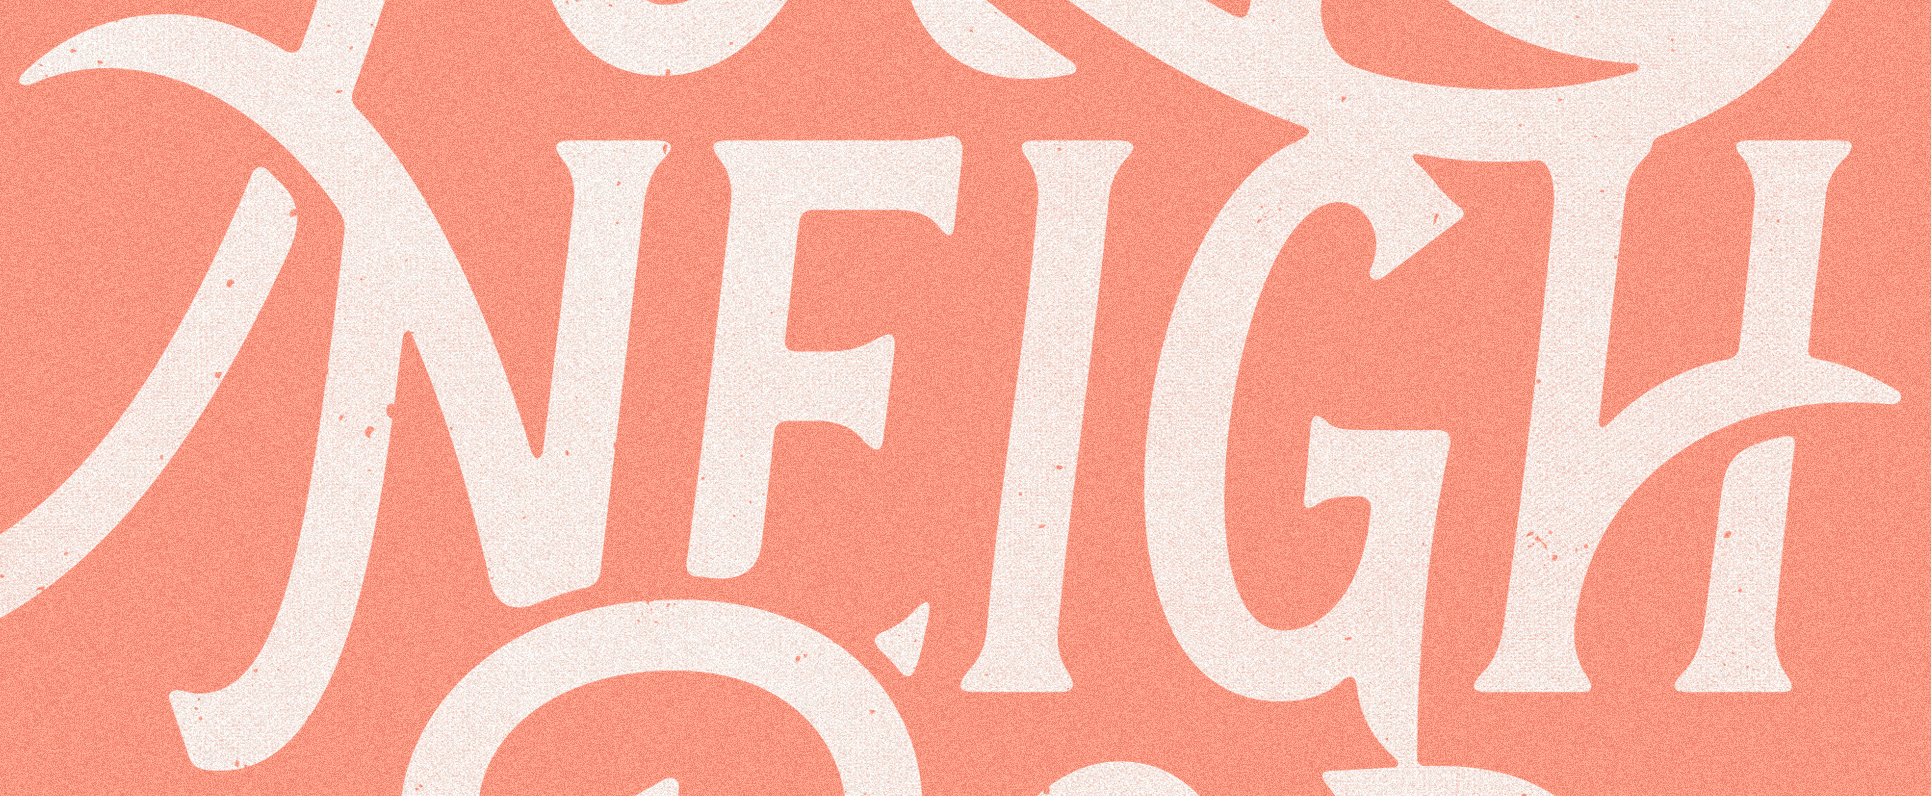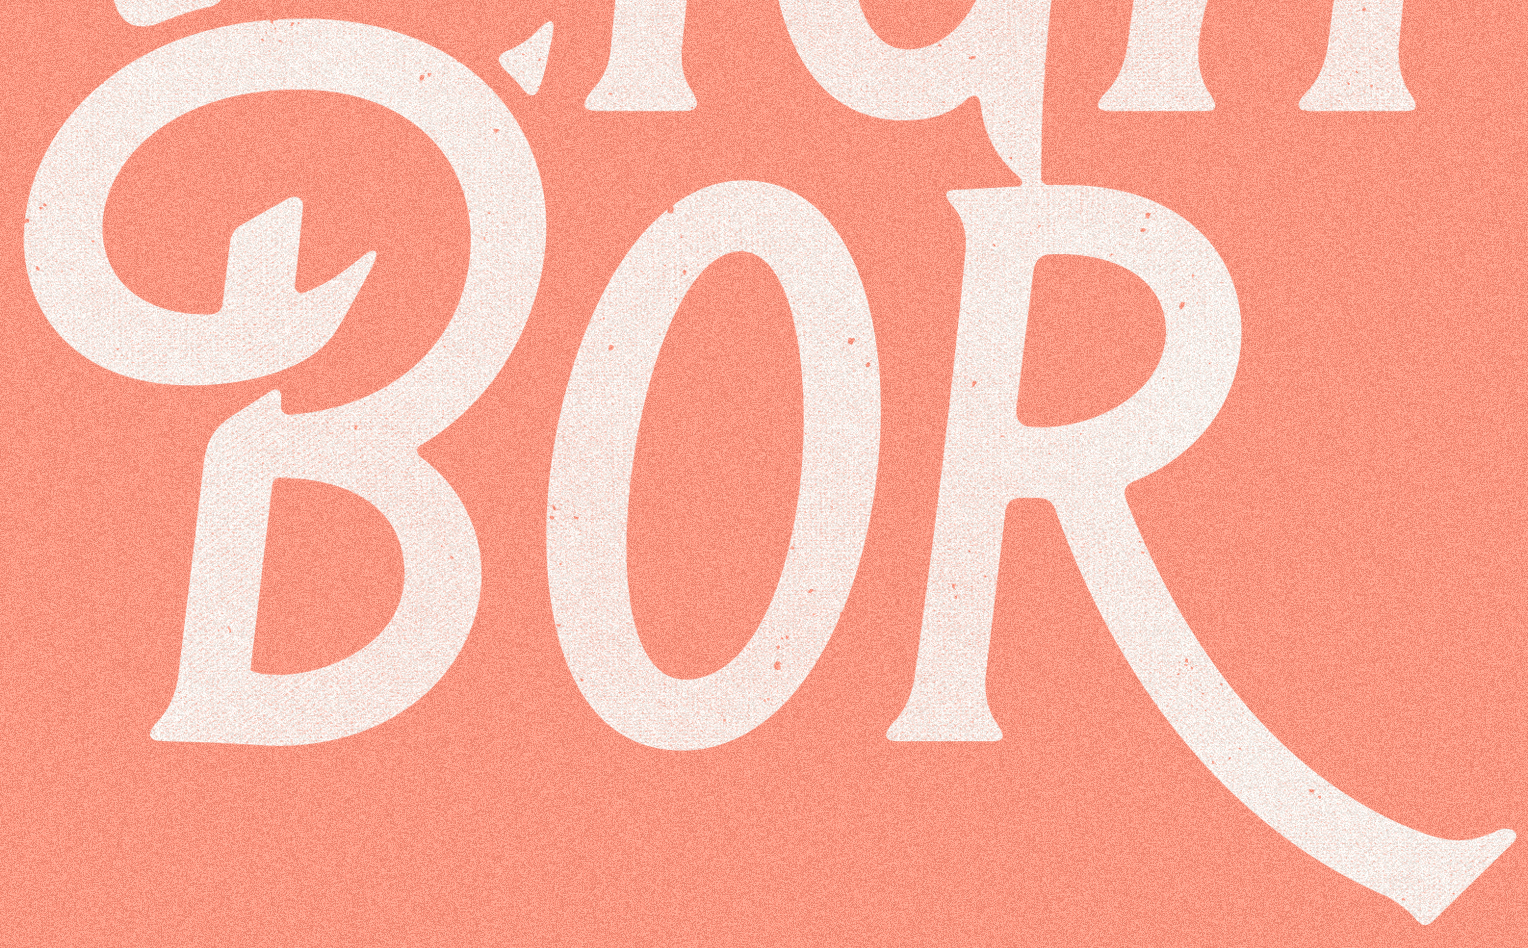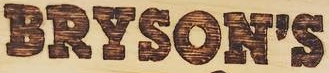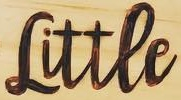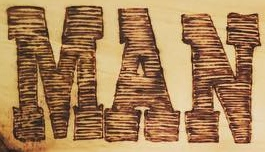What words are shown in these images in order, separated by a semicolon? NEIGH; BOR; BRYSON'S; Littee; MAN 